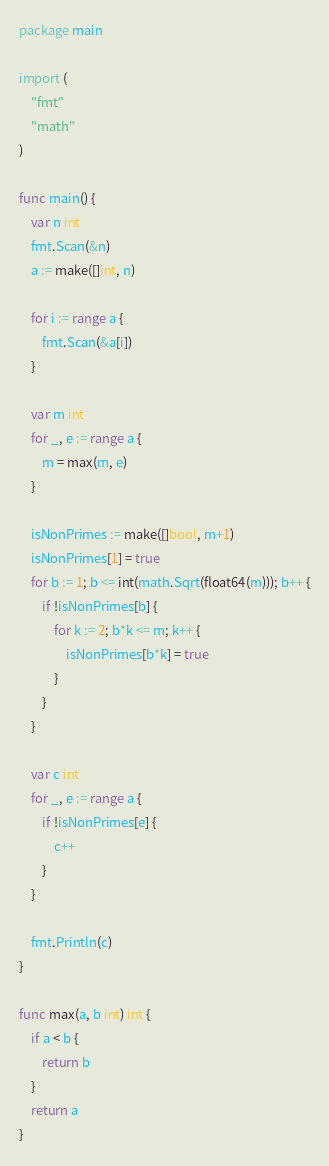Convert code to text. <code><loc_0><loc_0><loc_500><loc_500><_Go_>package main

import (
	"fmt"
	"math"
)

func main() {
	var n int
	fmt.Scan(&n)
	a := make([]int, n)

	for i := range a {
		fmt.Scan(&a[i])
	}

	var m int
	for _, e := range a {
		m = max(m, e)
	}

	isNonPrimes := make([]bool, m+1)
	isNonPrimes[1] = true
	for b := 1; b <= int(math.Sqrt(float64(m))); b++ {
		if !isNonPrimes[b] {
			for k := 2; b*k <= m; k++ {
				isNonPrimes[b*k] = true
			}
		}
	}

	var c int
	for _, e := range a {
		if !isNonPrimes[e] {
			c++
		}
	}

	fmt.Println(c)
}

func max(a, b int) int {
	if a < b {
		return b
	}
	return a
}

</code> 